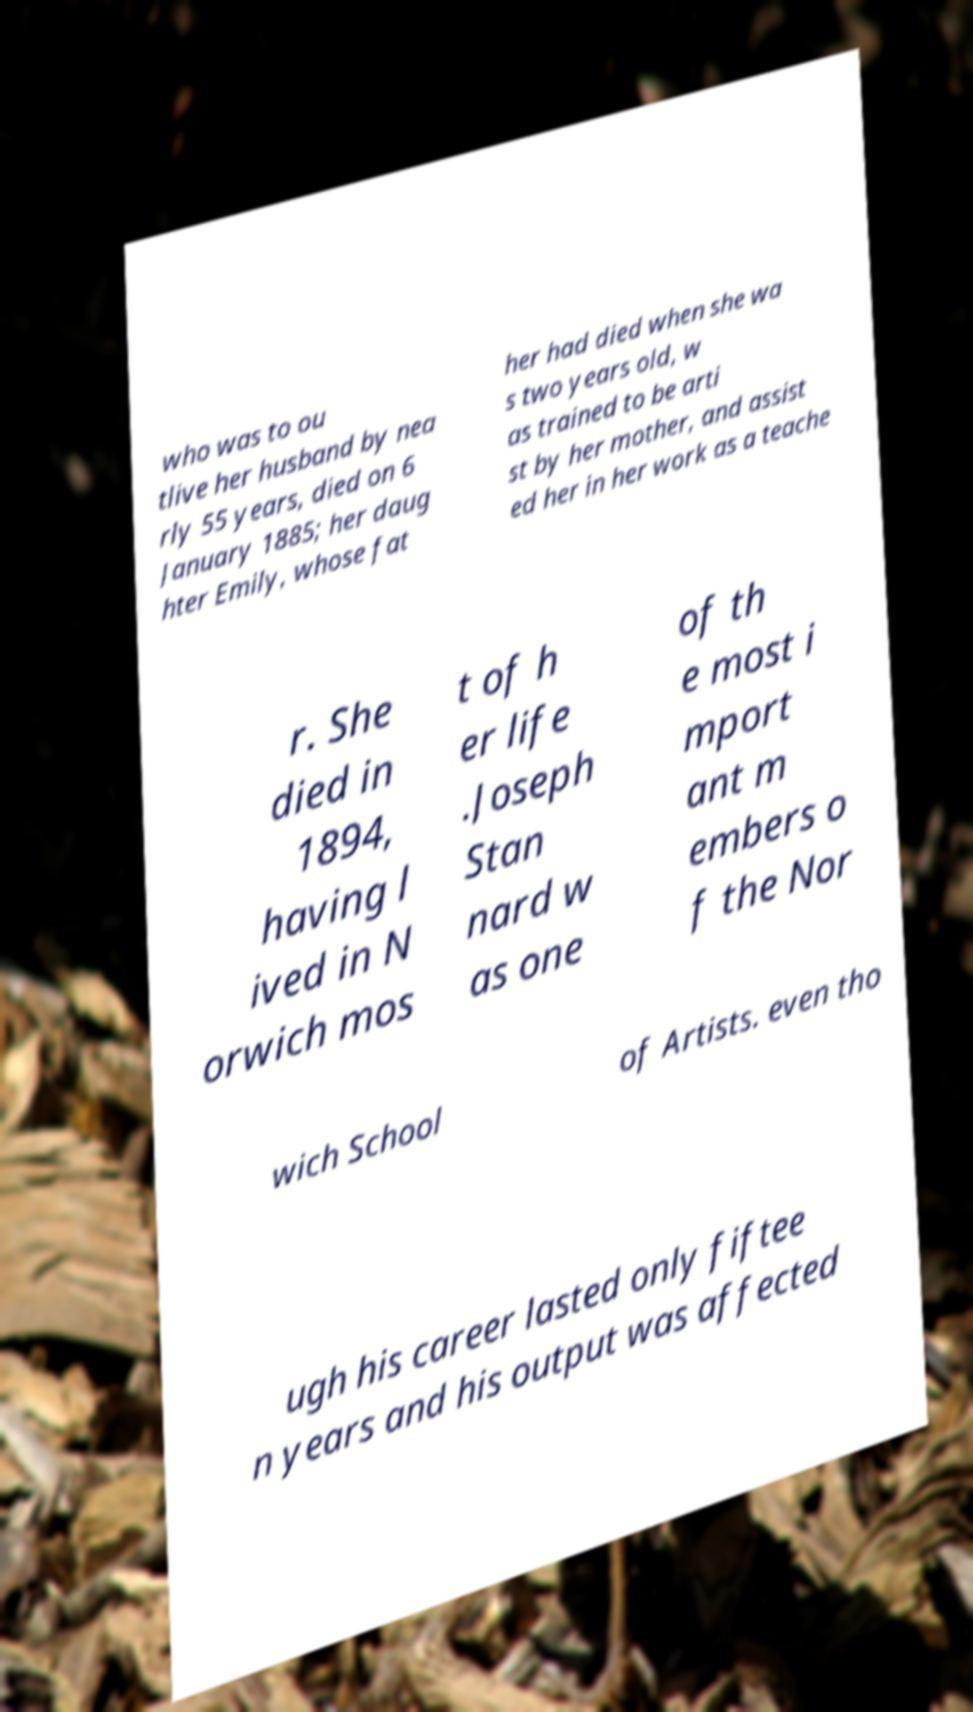There's text embedded in this image that I need extracted. Can you transcribe it verbatim? who was to ou tlive her husband by nea rly 55 years, died on 6 January 1885; her daug hter Emily, whose fat her had died when she wa s two years old, w as trained to be arti st by her mother, and assist ed her in her work as a teache r. She died in 1894, having l ived in N orwich mos t of h er life .Joseph Stan nard w as one of th e most i mport ant m embers o f the Nor wich School of Artists. even tho ugh his career lasted only fiftee n years and his output was affected 